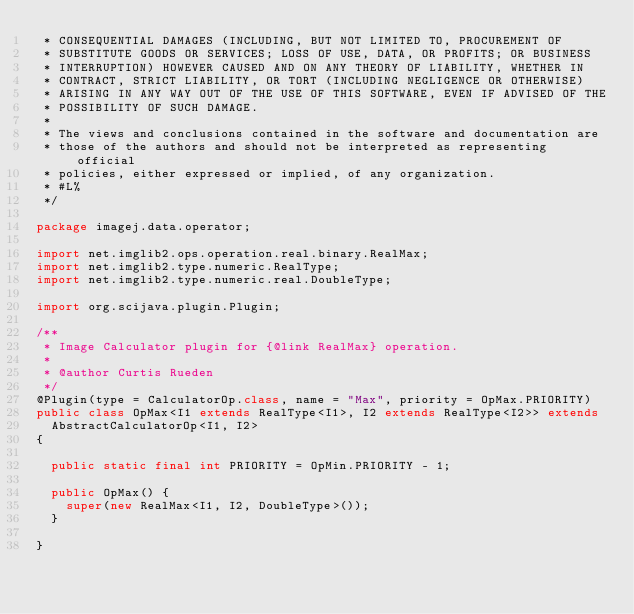<code> <loc_0><loc_0><loc_500><loc_500><_Java_> * CONSEQUENTIAL DAMAGES (INCLUDING, BUT NOT LIMITED TO, PROCUREMENT OF
 * SUBSTITUTE GOODS OR SERVICES; LOSS OF USE, DATA, OR PROFITS; OR BUSINESS
 * INTERRUPTION) HOWEVER CAUSED AND ON ANY THEORY OF LIABILITY, WHETHER IN
 * CONTRACT, STRICT LIABILITY, OR TORT (INCLUDING NEGLIGENCE OR OTHERWISE)
 * ARISING IN ANY WAY OUT OF THE USE OF THIS SOFTWARE, EVEN IF ADVISED OF THE
 * POSSIBILITY OF SUCH DAMAGE.
 * 
 * The views and conclusions contained in the software and documentation are
 * those of the authors and should not be interpreted as representing official
 * policies, either expressed or implied, of any organization.
 * #L%
 */

package imagej.data.operator;

import net.imglib2.ops.operation.real.binary.RealMax;
import net.imglib2.type.numeric.RealType;
import net.imglib2.type.numeric.real.DoubleType;

import org.scijava.plugin.Plugin;

/**
 * Image Calculator plugin for {@link RealMax} operation.
 * 
 * @author Curtis Rueden
 */
@Plugin(type = CalculatorOp.class, name = "Max", priority = OpMax.PRIORITY)
public class OpMax<I1 extends RealType<I1>, I2 extends RealType<I2>> extends
	AbstractCalculatorOp<I1, I2>
{

	public static final int PRIORITY = OpMin.PRIORITY - 1;

	public OpMax() {
		super(new RealMax<I1, I2, DoubleType>());
	}

}
</code> 